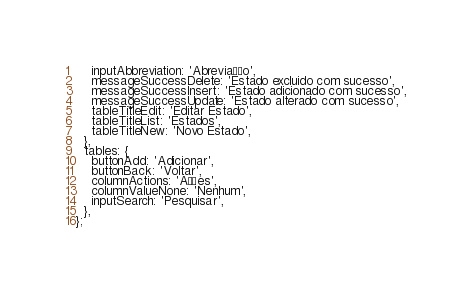<code> <loc_0><loc_0><loc_500><loc_500><_JavaScript_>    inputAbbreviation: 'Abreviação',
    messageSuccessDelete: 'Estado excluido com sucesso',
    messageSuccessInsert: 'Estado adicionado com sucesso',
    messageSuccessUpdate: 'Estado alterado com sucesso',
    tableTitleEdit: 'Editar Estado',
    tableTitleList: 'Estados',
    tableTitleNew: 'Novo Estado',
  },
  tables: {
    buttonAdd: 'Adicionar',
    buttonBack: 'Voltar',
    columnActions: 'Ações',
    columnValueNone: 'Nenhum',
    inputSearch: 'Pesquisar',
  },
};
</code> 